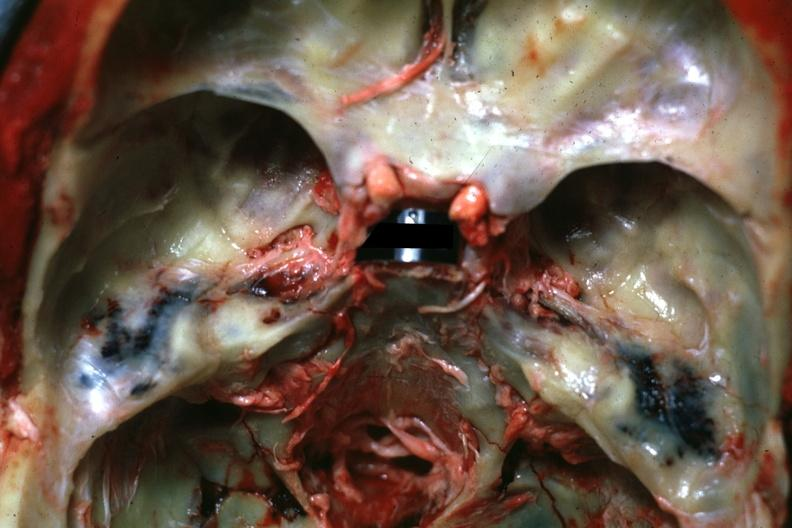s atheromatous embolus present?
Answer the question using a single word or phrase. No 